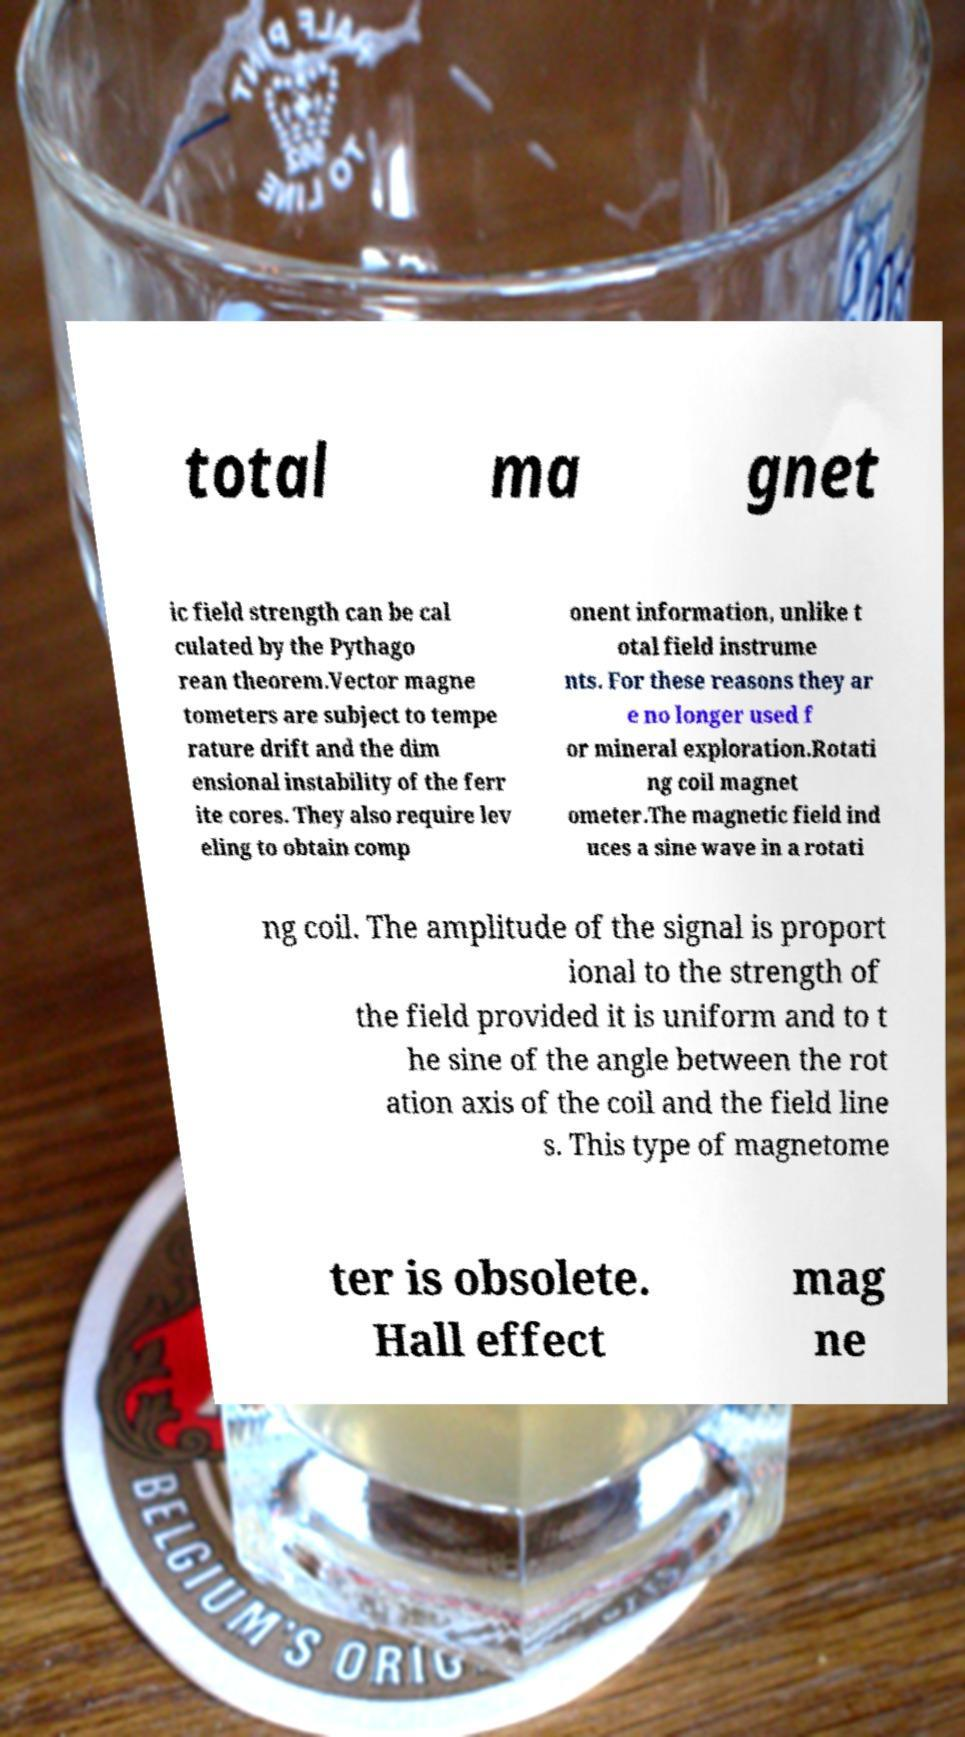There's text embedded in this image that I need extracted. Can you transcribe it verbatim? total ma gnet ic field strength can be cal culated by the Pythago rean theorem.Vector magne tometers are subject to tempe rature drift and the dim ensional instability of the ferr ite cores. They also require lev eling to obtain comp onent information, unlike t otal field instrume nts. For these reasons they ar e no longer used f or mineral exploration.Rotati ng coil magnet ometer.The magnetic field ind uces a sine wave in a rotati ng coil. The amplitude of the signal is proport ional to the strength of the field provided it is uniform and to t he sine of the angle between the rot ation axis of the coil and the field line s. This type of magnetome ter is obsolete. Hall effect mag ne 